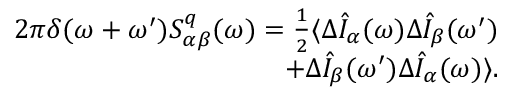<formula> <loc_0><loc_0><loc_500><loc_500>\begin{array} { r } { 2 \pi \delta ( \omega + \omega ^ { \prime } ) S _ { \alpha \beta } ^ { q } ( \omega ) = \frac { 1 } { 2 } \langle \Delta \hat { I } _ { \alpha } ( \omega ) \Delta \hat { I } _ { \beta } ( \omega ^ { \prime } ) } \\ { + \Delta \hat { I } _ { \beta } ( \omega ^ { \prime } ) \Delta \hat { I } _ { \alpha } ( \omega ) \rangle . } \end{array}</formula> 